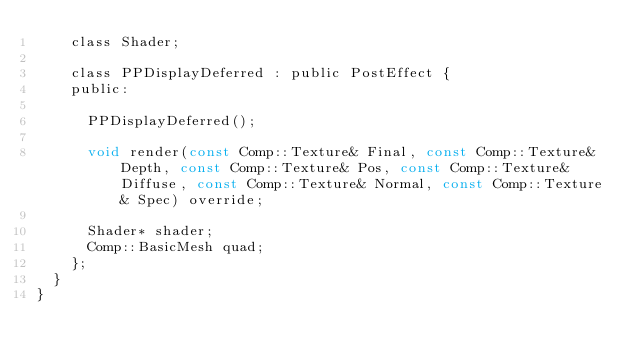<code> <loc_0><loc_0><loc_500><loc_500><_C_>		class Shader;

		class PPDisplayDeferred : public PostEffect {
		public:

			PPDisplayDeferred();

			void render(const Comp::Texture& Final, const Comp::Texture& Depth, const Comp::Texture& Pos, const Comp::Texture& Diffuse, const Comp::Texture& Normal, const Comp::Texture& Spec) override;

			Shader* shader;
			Comp::BasicMesh quad;
		};
	}
}</code> 